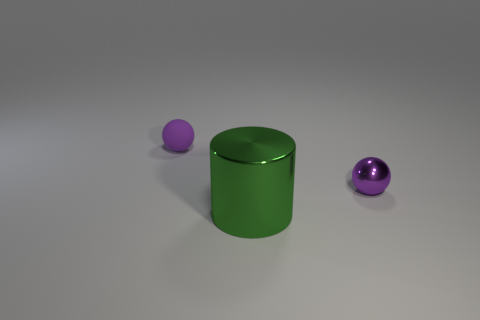What number of other objects are there of the same size as the green metal cylinder?
Provide a short and direct response. 0. What number of matte balls are left of the green cylinder?
Offer a terse response. 1. Are there an equal number of big metallic cylinders left of the large green object and purple spheres on the right side of the small purple rubber object?
Give a very brief answer. No. There is a tiny purple object that is in front of the purple matte ball; what is its shape?
Offer a very short reply. Sphere. Do the object that is right of the green metallic cylinder and the large green thing that is in front of the rubber object have the same material?
Give a very brief answer. Yes. There is a big shiny object; what shape is it?
Your answer should be very brief. Cylinder. Is the number of purple objects that are in front of the green metallic cylinder the same as the number of yellow matte spheres?
Ensure brevity in your answer.  Yes. Are there any balls that have the same material as the big green thing?
Offer a very short reply. Yes. Is the shape of the small object in front of the tiny purple rubber thing the same as the object that is to the left of the big metallic object?
Provide a succinct answer. Yes. Are there any shiny objects?
Provide a short and direct response. Yes. 